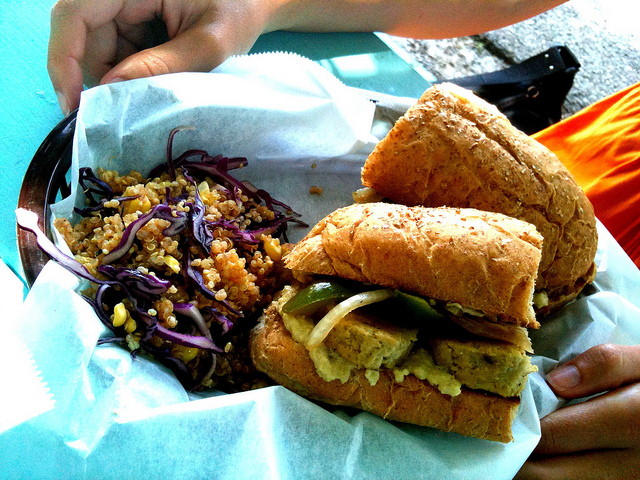Can you describe the healthiness of this meal? Certainly! Judging from the image, the meal seems to present a wholesome balance. The sandwich is filled with what appears to be a variety of grilled vegetables, which are a nutritious choice. The side salad includes quinoa and red cabbage, both of which are known for their health benefits, such as being high in fiber and essential nutrients. However, without knowing the specific ingredients or cooking methods used, it’s difficult to make an accurate assessment of the overall healthiness. 